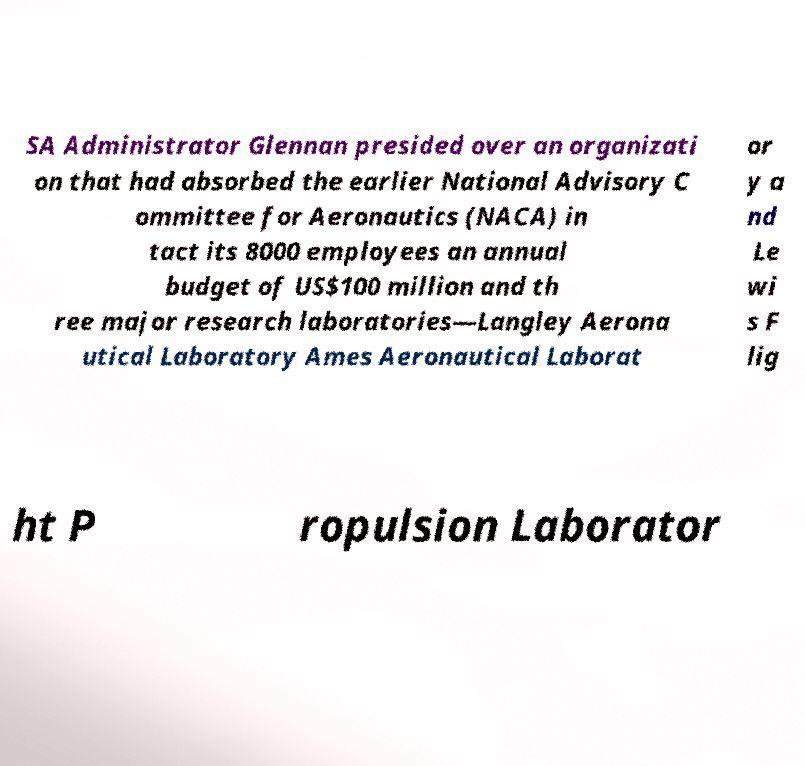Could you extract and type out the text from this image? SA Administrator Glennan presided over an organizati on that had absorbed the earlier National Advisory C ommittee for Aeronautics (NACA) in tact its 8000 employees an annual budget of US$100 million and th ree major research laboratories—Langley Aerona utical Laboratory Ames Aeronautical Laborat or y a nd Le wi s F lig ht P ropulsion Laborator 